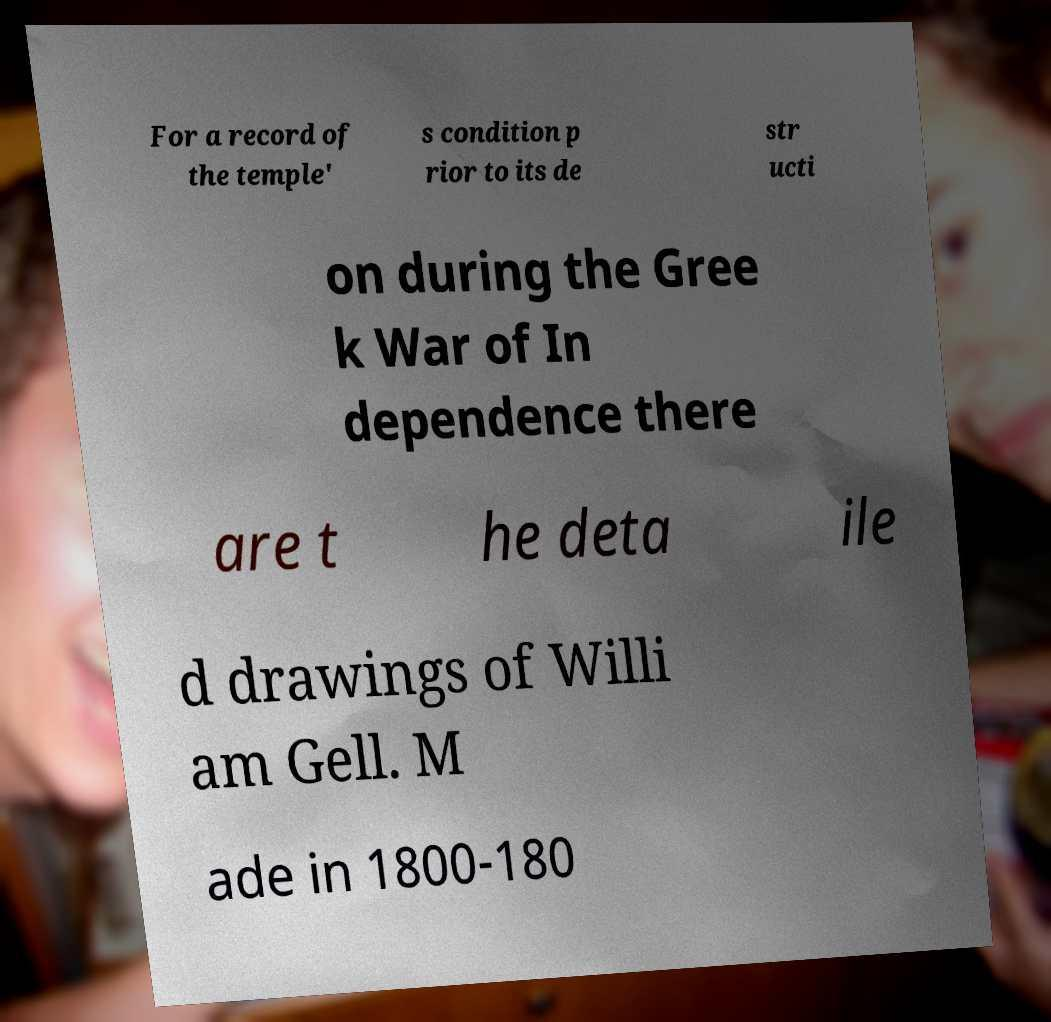Please identify and transcribe the text found in this image. For a record of the temple' s condition p rior to its de str ucti on during the Gree k War of In dependence there are t he deta ile d drawings of Willi am Gell. M ade in 1800-180 